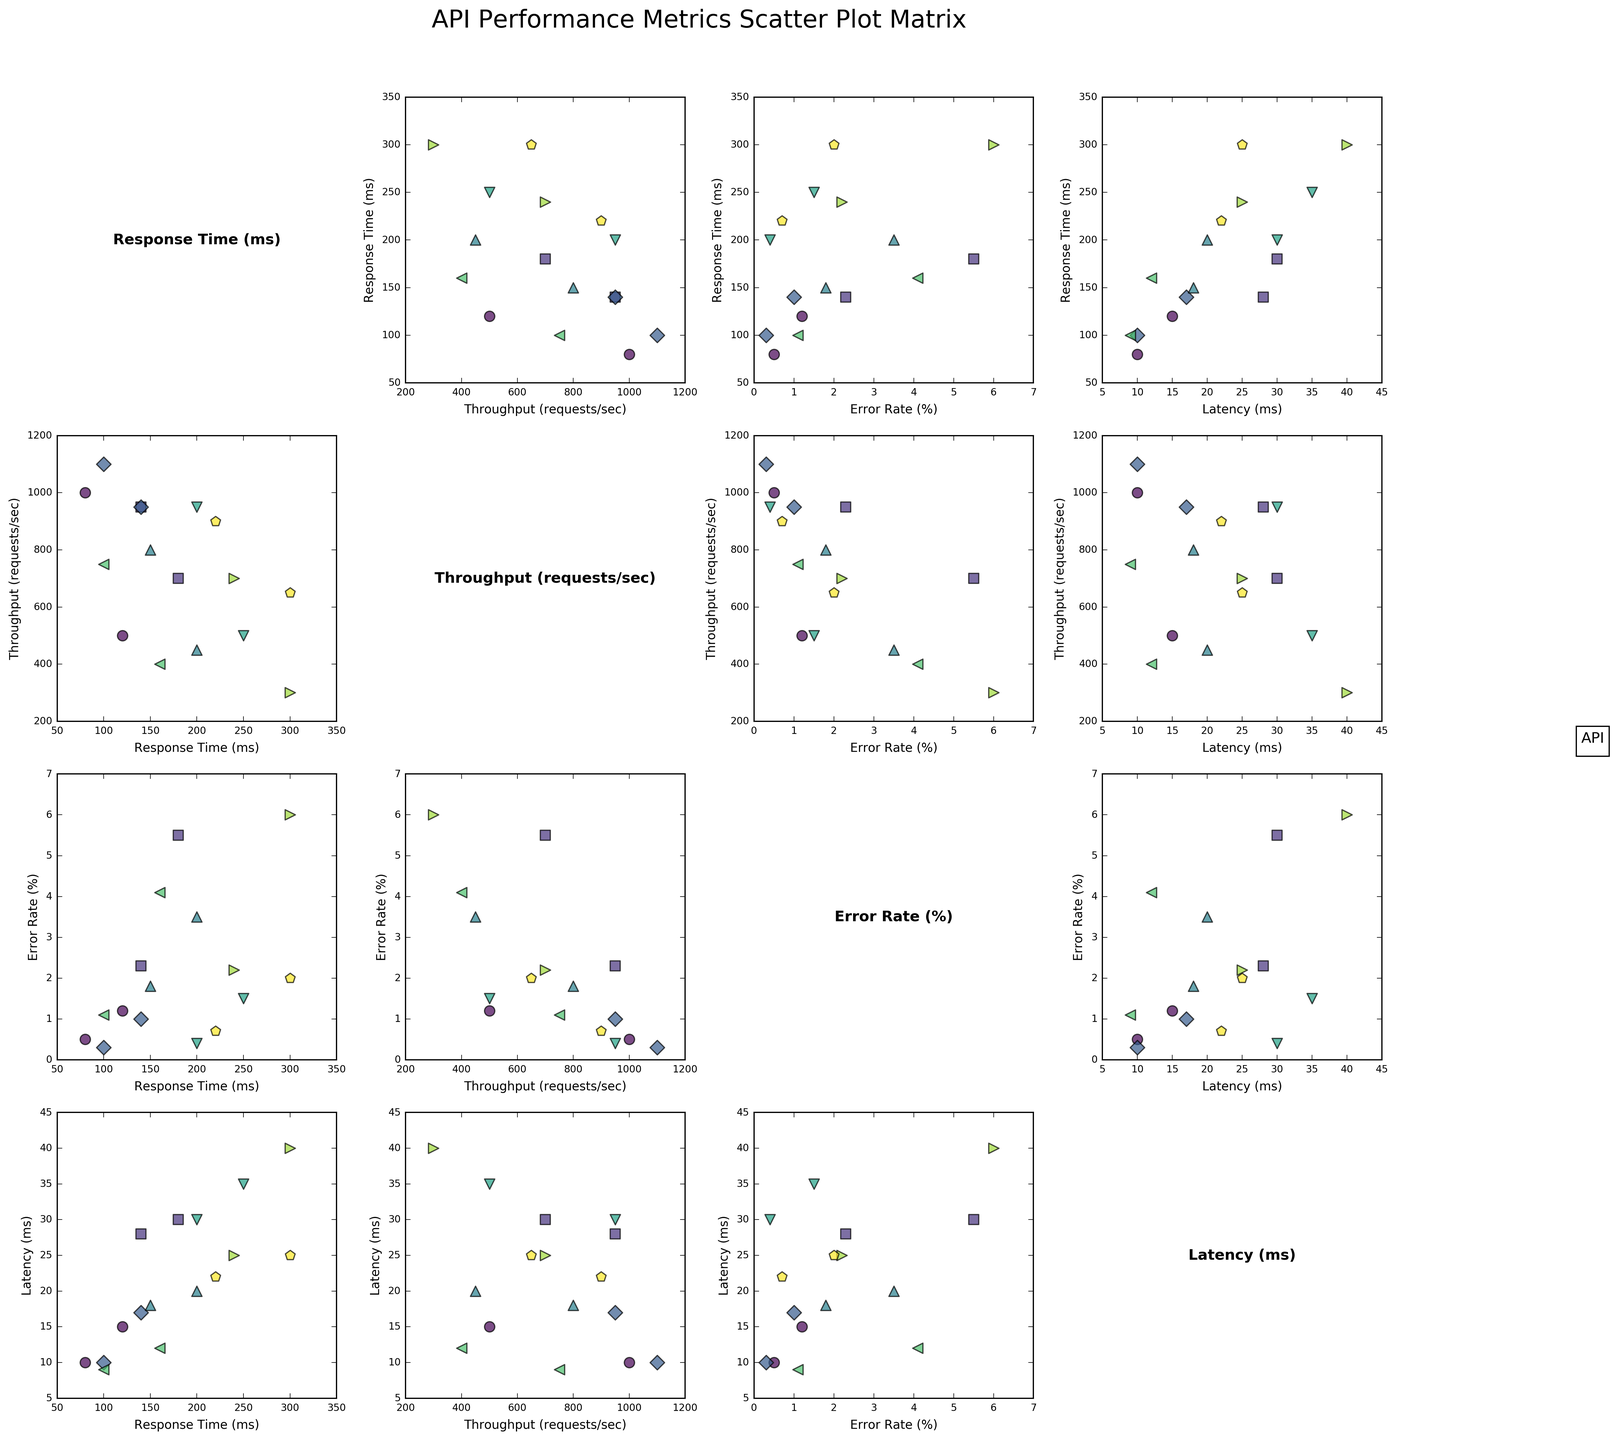What is the title of the figure? The title is usually placed at the top of the figure, serving as an overview of what the figure represents. Here, it can be found in large text above the grid of scatter plots.
Answer: API Performance Metrics Scatter Plot Matrix How many different APIs are represented in the scatter plot matrix? By looking at the legend, there are multiple markers, each representing a unique API. Counting the distinct markers gives the total number of unique APIs.
Answer: 8 Which API has the highest error rate during its peak usage scenario? To find the API with the highest error rate, look at the scatter plot with "Error Rate (%)" on one of the axes and identify the marker that reaches the highest point.
Answer: TravelAPI Do higher error rates generally correspond to higher response times? By examining scatter plots where error rate and response time are on the axes, you can identify trends. If points tend to move upward together, there is a positive correlation.
Answer: Yes What are the axes labeled in the scatter plot matrix? Each axis in the scatter plot matrix is labeled based on the metrics being compared. Checking the scatter plots surrounding the diagonal axis will provide these labels.
Answer: Response Time (ms), Throughput (requests/sec), Error Rate (%), Latency (ms) Which API has the highest throughput during low traffic conditions? Identify the scatter plots with throughput on one of the axes and inspect the points labeled for low traffic conditions to find the highest value.
Answer: NewsAPI Is there any relationship observed between latency and response time? By examining the scatter plots where latency and response time are compared, look for any visible patterns or trends indicating a relationship.
Answer: Yes How does the throughput of PaymentAPI compare during peak and off-peak hours? Check the scatter plots with throughput on one axis and find the markers for PaymentAPI during peak and off-peak hours, then compare their positions.
Answer: Higher during off-peak hours Which metric on the diagonal appears most frequently? Since each diagonal cell lists metrics, count the number of times each unique metric appears to identify the most frequent one.
Answer: Equal frequency for all Does the SocialAPI show a significant change in any of the metrics between high and low engagement scenarios? Review the scatter plots for metrics where SocialAPI is plotted, comparing the positions of points for high and low engagement. Significant changes would show substantial differences in point positions.
Answer: Yes 